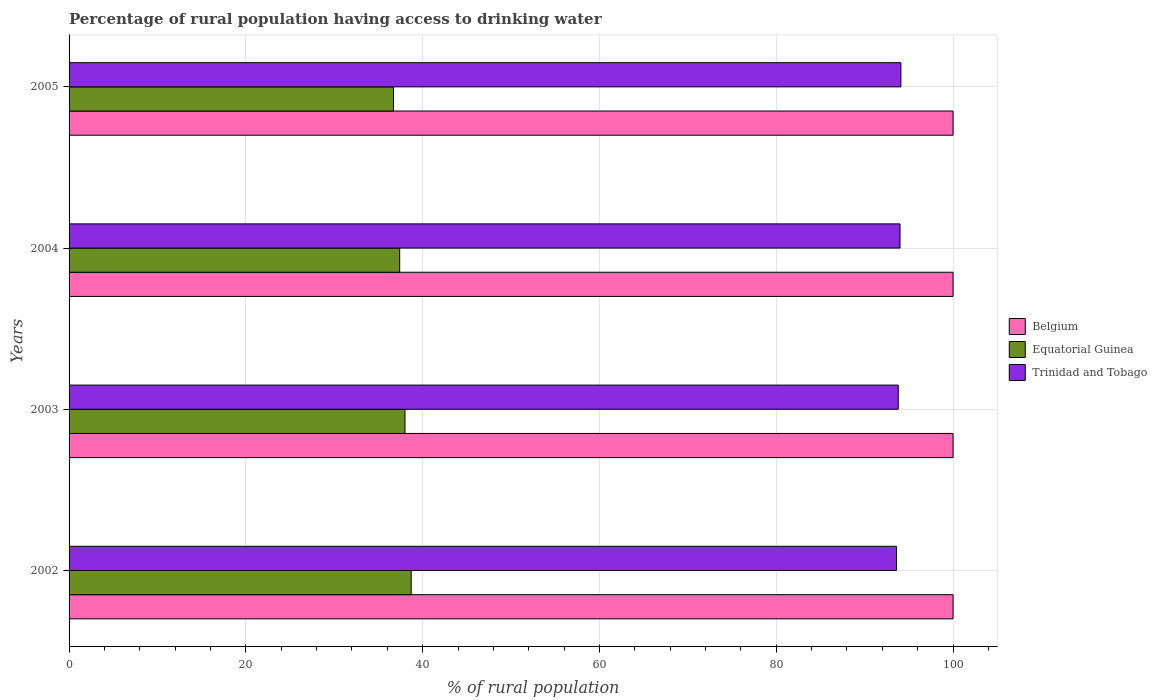How many groups of bars are there?
Give a very brief answer. 4. How many bars are there on the 1st tick from the bottom?
Your answer should be compact. 3. What is the label of the 3rd group of bars from the top?
Make the answer very short. 2003. In how many cases, is the number of bars for a given year not equal to the number of legend labels?
Your answer should be very brief. 0. What is the percentage of rural population having access to drinking water in Belgium in 2005?
Make the answer very short. 100. Across all years, what is the maximum percentage of rural population having access to drinking water in Belgium?
Give a very brief answer. 100. Across all years, what is the minimum percentage of rural population having access to drinking water in Trinidad and Tobago?
Offer a very short reply. 93.6. In which year was the percentage of rural population having access to drinking water in Equatorial Guinea maximum?
Your response must be concise. 2002. What is the total percentage of rural population having access to drinking water in Trinidad and Tobago in the graph?
Your answer should be compact. 375.5. What is the difference between the percentage of rural population having access to drinking water in Equatorial Guinea in 2003 and that in 2004?
Ensure brevity in your answer.  0.6. What is the difference between the percentage of rural population having access to drinking water in Equatorial Guinea in 2005 and the percentage of rural population having access to drinking water in Trinidad and Tobago in 2002?
Ensure brevity in your answer.  -56.9. What is the average percentage of rural population having access to drinking water in Trinidad and Tobago per year?
Ensure brevity in your answer.  93.88. What is the ratio of the percentage of rural population having access to drinking water in Belgium in 2002 to that in 2004?
Offer a very short reply. 1. Is the difference between the percentage of rural population having access to drinking water in Trinidad and Tobago in 2002 and 2004 greater than the difference between the percentage of rural population having access to drinking water in Belgium in 2002 and 2004?
Keep it short and to the point. No. What is the difference between the highest and the second highest percentage of rural population having access to drinking water in Equatorial Guinea?
Your answer should be very brief. 0.7. What is the difference between the highest and the lowest percentage of rural population having access to drinking water in Belgium?
Provide a succinct answer. 0. In how many years, is the percentage of rural population having access to drinking water in Trinidad and Tobago greater than the average percentage of rural population having access to drinking water in Trinidad and Tobago taken over all years?
Offer a terse response. 2. Is the sum of the percentage of rural population having access to drinking water in Equatorial Guinea in 2002 and 2003 greater than the maximum percentage of rural population having access to drinking water in Belgium across all years?
Offer a very short reply. No. What does the 1st bar from the top in 2003 represents?
Keep it short and to the point. Trinidad and Tobago. What does the 2nd bar from the bottom in 2003 represents?
Your answer should be very brief. Equatorial Guinea. How many bars are there?
Make the answer very short. 12. Are all the bars in the graph horizontal?
Keep it short and to the point. Yes. How many years are there in the graph?
Give a very brief answer. 4. What is the difference between two consecutive major ticks on the X-axis?
Keep it short and to the point. 20. Are the values on the major ticks of X-axis written in scientific E-notation?
Your answer should be compact. No. Does the graph contain any zero values?
Provide a short and direct response. No. What is the title of the graph?
Make the answer very short. Percentage of rural population having access to drinking water. What is the label or title of the X-axis?
Make the answer very short. % of rural population. What is the label or title of the Y-axis?
Make the answer very short. Years. What is the % of rural population in Equatorial Guinea in 2002?
Your response must be concise. 38.7. What is the % of rural population of Trinidad and Tobago in 2002?
Offer a very short reply. 93.6. What is the % of rural population in Belgium in 2003?
Keep it short and to the point. 100. What is the % of rural population in Trinidad and Tobago in 2003?
Your answer should be compact. 93.8. What is the % of rural population of Belgium in 2004?
Provide a succinct answer. 100. What is the % of rural population in Equatorial Guinea in 2004?
Provide a succinct answer. 37.4. What is the % of rural population of Trinidad and Tobago in 2004?
Offer a very short reply. 94. What is the % of rural population of Belgium in 2005?
Your answer should be compact. 100. What is the % of rural population in Equatorial Guinea in 2005?
Provide a succinct answer. 36.7. What is the % of rural population in Trinidad and Tobago in 2005?
Keep it short and to the point. 94.1. Across all years, what is the maximum % of rural population of Belgium?
Provide a short and direct response. 100. Across all years, what is the maximum % of rural population of Equatorial Guinea?
Your answer should be very brief. 38.7. Across all years, what is the maximum % of rural population in Trinidad and Tobago?
Offer a very short reply. 94.1. Across all years, what is the minimum % of rural population in Equatorial Guinea?
Your answer should be compact. 36.7. Across all years, what is the minimum % of rural population of Trinidad and Tobago?
Provide a short and direct response. 93.6. What is the total % of rural population in Equatorial Guinea in the graph?
Give a very brief answer. 150.8. What is the total % of rural population in Trinidad and Tobago in the graph?
Make the answer very short. 375.5. What is the difference between the % of rural population of Equatorial Guinea in 2002 and that in 2003?
Offer a very short reply. 0.7. What is the difference between the % of rural population of Belgium in 2002 and that in 2004?
Provide a short and direct response. 0. What is the difference between the % of rural population of Equatorial Guinea in 2002 and that in 2004?
Give a very brief answer. 1.3. What is the difference between the % of rural population of Trinidad and Tobago in 2002 and that in 2004?
Provide a succinct answer. -0.4. What is the difference between the % of rural population in Belgium in 2002 and that in 2005?
Provide a succinct answer. 0. What is the difference between the % of rural population in Equatorial Guinea in 2002 and that in 2005?
Offer a terse response. 2. What is the difference between the % of rural population in Trinidad and Tobago in 2002 and that in 2005?
Offer a very short reply. -0.5. What is the difference between the % of rural population of Belgium in 2003 and that in 2004?
Ensure brevity in your answer.  0. What is the difference between the % of rural population in Equatorial Guinea in 2003 and that in 2004?
Keep it short and to the point. 0.6. What is the difference between the % of rural population in Trinidad and Tobago in 2003 and that in 2004?
Make the answer very short. -0.2. What is the difference between the % of rural population of Trinidad and Tobago in 2003 and that in 2005?
Ensure brevity in your answer.  -0.3. What is the difference between the % of rural population in Belgium in 2004 and that in 2005?
Make the answer very short. 0. What is the difference between the % of rural population of Equatorial Guinea in 2004 and that in 2005?
Your answer should be compact. 0.7. What is the difference between the % of rural population in Equatorial Guinea in 2002 and the % of rural population in Trinidad and Tobago in 2003?
Give a very brief answer. -55.1. What is the difference between the % of rural population in Belgium in 2002 and the % of rural population in Equatorial Guinea in 2004?
Your answer should be very brief. 62.6. What is the difference between the % of rural population in Belgium in 2002 and the % of rural population in Trinidad and Tobago in 2004?
Give a very brief answer. 6. What is the difference between the % of rural population of Equatorial Guinea in 2002 and the % of rural population of Trinidad and Tobago in 2004?
Make the answer very short. -55.3. What is the difference between the % of rural population in Belgium in 2002 and the % of rural population in Equatorial Guinea in 2005?
Offer a very short reply. 63.3. What is the difference between the % of rural population of Belgium in 2002 and the % of rural population of Trinidad and Tobago in 2005?
Give a very brief answer. 5.9. What is the difference between the % of rural population of Equatorial Guinea in 2002 and the % of rural population of Trinidad and Tobago in 2005?
Make the answer very short. -55.4. What is the difference between the % of rural population in Belgium in 2003 and the % of rural population in Equatorial Guinea in 2004?
Provide a short and direct response. 62.6. What is the difference between the % of rural population of Belgium in 2003 and the % of rural population of Trinidad and Tobago in 2004?
Keep it short and to the point. 6. What is the difference between the % of rural population in Equatorial Guinea in 2003 and the % of rural population in Trinidad and Tobago in 2004?
Your response must be concise. -56. What is the difference between the % of rural population in Belgium in 2003 and the % of rural population in Equatorial Guinea in 2005?
Make the answer very short. 63.3. What is the difference between the % of rural population in Belgium in 2003 and the % of rural population in Trinidad and Tobago in 2005?
Ensure brevity in your answer.  5.9. What is the difference between the % of rural population of Equatorial Guinea in 2003 and the % of rural population of Trinidad and Tobago in 2005?
Offer a very short reply. -56.1. What is the difference between the % of rural population of Belgium in 2004 and the % of rural population of Equatorial Guinea in 2005?
Your answer should be compact. 63.3. What is the difference between the % of rural population of Equatorial Guinea in 2004 and the % of rural population of Trinidad and Tobago in 2005?
Offer a terse response. -56.7. What is the average % of rural population in Belgium per year?
Your answer should be compact. 100. What is the average % of rural population of Equatorial Guinea per year?
Offer a terse response. 37.7. What is the average % of rural population in Trinidad and Tobago per year?
Make the answer very short. 93.88. In the year 2002, what is the difference between the % of rural population of Belgium and % of rural population of Equatorial Guinea?
Ensure brevity in your answer.  61.3. In the year 2002, what is the difference between the % of rural population of Equatorial Guinea and % of rural population of Trinidad and Tobago?
Offer a very short reply. -54.9. In the year 2003, what is the difference between the % of rural population of Equatorial Guinea and % of rural population of Trinidad and Tobago?
Make the answer very short. -55.8. In the year 2004, what is the difference between the % of rural population of Belgium and % of rural population of Equatorial Guinea?
Make the answer very short. 62.6. In the year 2004, what is the difference between the % of rural population in Equatorial Guinea and % of rural population in Trinidad and Tobago?
Keep it short and to the point. -56.6. In the year 2005, what is the difference between the % of rural population of Belgium and % of rural population of Equatorial Guinea?
Make the answer very short. 63.3. In the year 2005, what is the difference between the % of rural population in Belgium and % of rural population in Trinidad and Tobago?
Your response must be concise. 5.9. In the year 2005, what is the difference between the % of rural population of Equatorial Guinea and % of rural population of Trinidad and Tobago?
Your response must be concise. -57.4. What is the ratio of the % of rural population of Belgium in 2002 to that in 2003?
Make the answer very short. 1. What is the ratio of the % of rural population in Equatorial Guinea in 2002 to that in 2003?
Provide a short and direct response. 1.02. What is the ratio of the % of rural population of Belgium in 2002 to that in 2004?
Provide a succinct answer. 1. What is the ratio of the % of rural population of Equatorial Guinea in 2002 to that in 2004?
Your response must be concise. 1.03. What is the ratio of the % of rural population of Trinidad and Tobago in 2002 to that in 2004?
Provide a succinct answer. 1. What is the ratio of the % of rural population in Belgium in 2002 to that in 2005?
Provide a short and direct response. 1. What is the ratio of the % of rural population of Equatorial Guinea in 2002 to that in 2005?
Provide a succinct answer. 1.05. What is the ratio of the % of rural population of Trinidad and Tobago in 2002 to that in 2005?
Your answer should be very brief. 0.99. What is the ratio of the % of rural population of Belgium in 2003 to that in 2004?
Give a very brief answer. 1. What is the ratio of the % of rural population of Belgium in 2003 to that in 2005?
Provide a succinct answer. 1. What is the ratio of the % of rural population of Equatorial Guinea in 2003 to that in 2005?
Provide a short and direct response. 1.04. What is the ratio of the % of rural population in Trinidad and Tobago in 2003 to that in 2005?
Make the answer very short. 1. What is the ratio of the % of rural population of Belgium in 2004 to that in 2005?
Offer a terse response. 1. What is the ratio of the % of rural population in Equatorial Guinea in 2004 to that in 2005?
Provide a short and direct response. 1.02. What is the difference between the highest and the second highest % of rural population of Trinidad and Tobago?
Make the answer very short. 0.1. What is the difference between the highest and the lowest % of rural population in Trinidad and Tobago?
Offer a terse response. 0.5. 